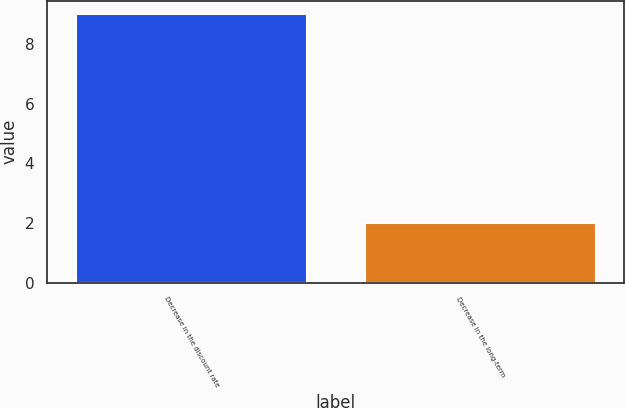Convert chart. <chart><loc_0><loc_0><loc_500><loc_500><bar_chart><fcel>Decrease in the discount rate<fcel>Decrease in the long-term<nl><fcel>9<fcel>2<nl></chart> 